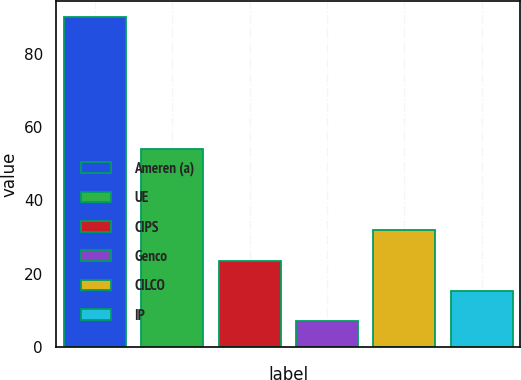Convert chart to OTSL. <chart><loc_0><loc_0><loc_500><loc_500><bar_chart><fcel>Ameren (a)<fcel>UE<fcel>CIPS<fcel>Genco<fcel>CILCO<fcel>IP<nl><fcel>90<fcel>54<fcel>23.6<fcel>7<fcel>31.9<fcel>15.3<nl></chart> 